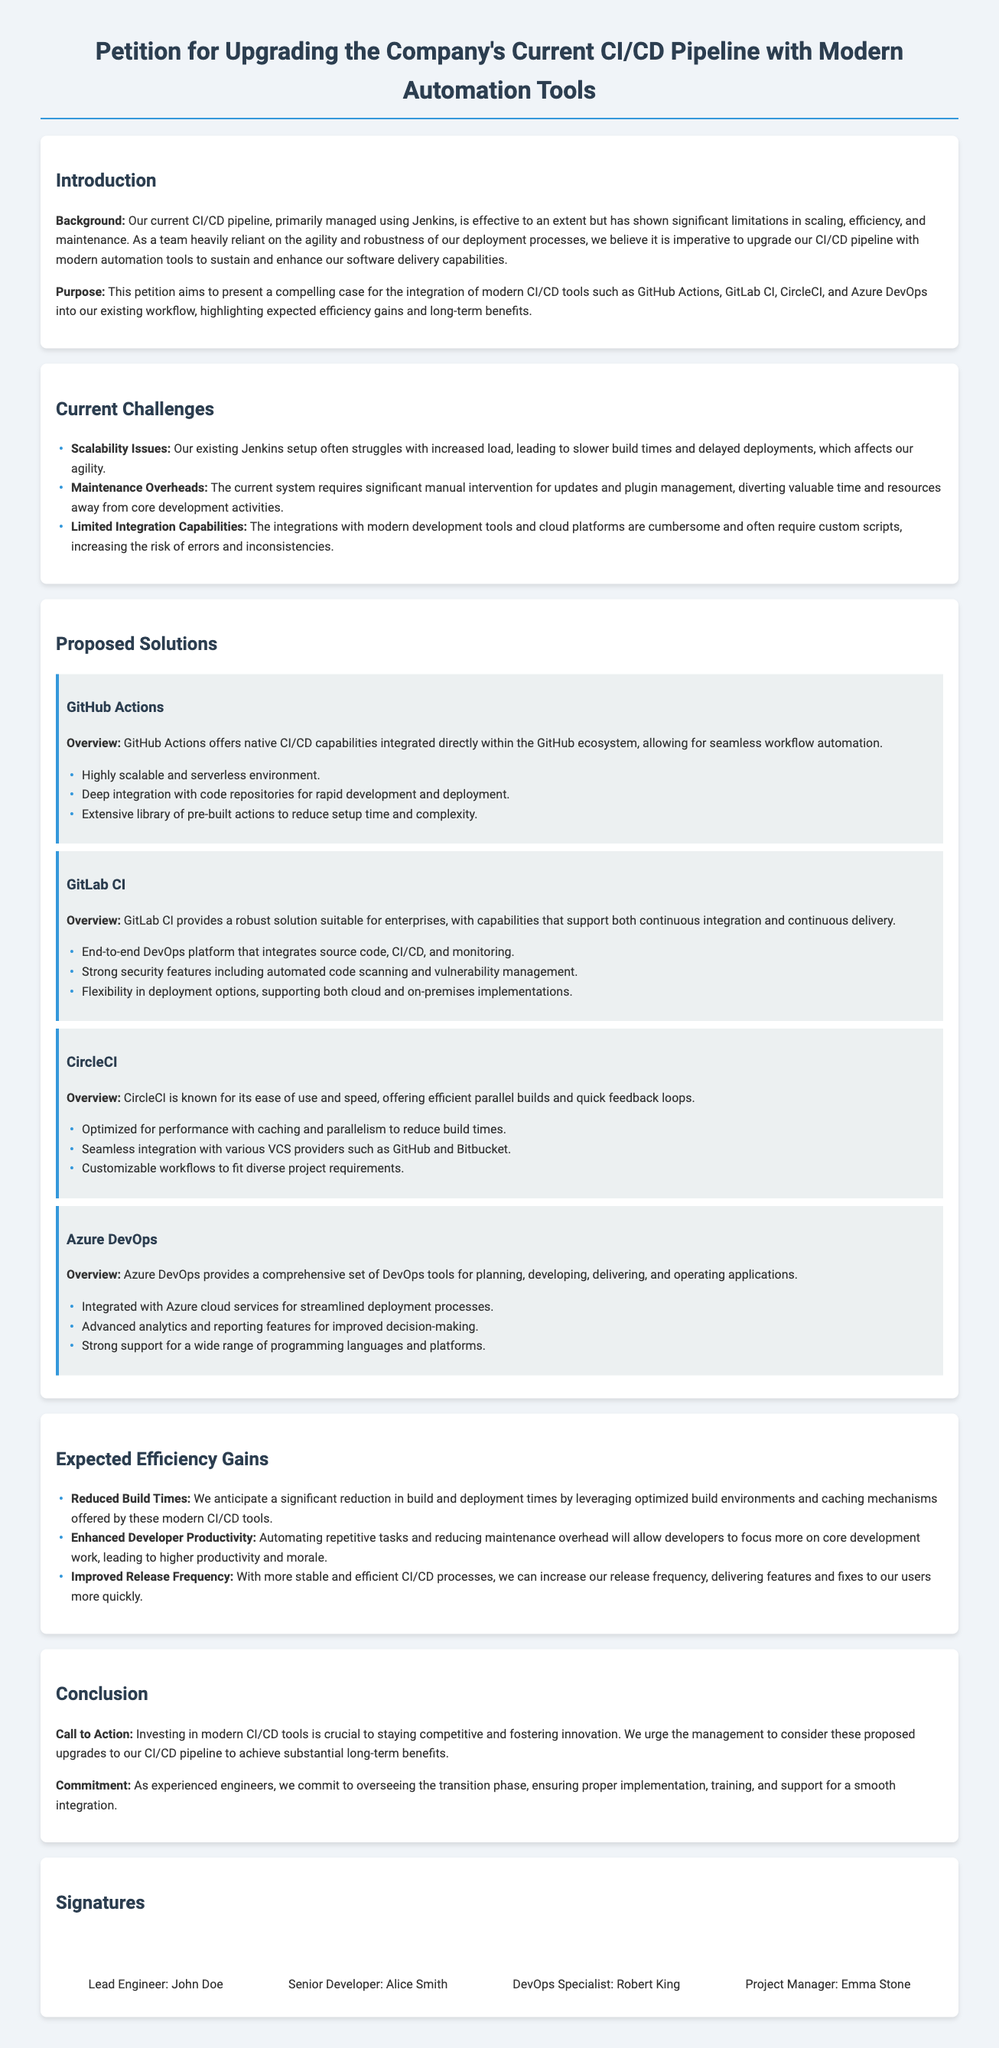What is the primary tool currently used for CI/CD? The document states that the current CI/CD pipeline is primarily managed using Jenkins.
Answer: Jenkins What are the proposed modern tools for the CI/CD pipeline? The document lists GitHub Actions, GitLab CI, CircleCI, and Azure DevOps as proposed modern tools.
Answer: GitHub Actions, GitLab CI, CircleCI, Azure DevOps What is one of the current challenges mentioned in the document? The document mentions scalability issues, maintenance overheads, and limited integration capabilities as current challenges.
Answer: Scalability issues How many signatures are provided at the end of the petition? The document includes signatures from four individuals: John Doe, Alice Smith, Robert King, and Emma Stone.
Answer: Four What benefit is expected from reducing maintenance overhead? The document states that reducing maintenance overhead will allow developers to focus more on core development work, leading to higher productivity and morale.
Answer: Higher productivity What is the call to action mentioned in the conclusion? The document urges management to consider proposed upgrades to the CI/CD pipeline.
Answer: Consider proposed upgrades What type of integration does GitHub Actions provide? The document specifies that GitHub Actions offers native CI/CD capabilities integrated directly within the GitHub ecosystem.
Answer: Native CI/CD capabilities Which proposed tool is noted for advanced analytics? The document mentions that Azure DevOps provides advanced analytics and reporting features.
Answer: Azure DevOps What do the proposed tools aim to achieve according to the document? The document highlights that the proposed tools aim to sustain and enhance software delivery capabilities.
Answer: Sustain and enhance software delivery capabilities 